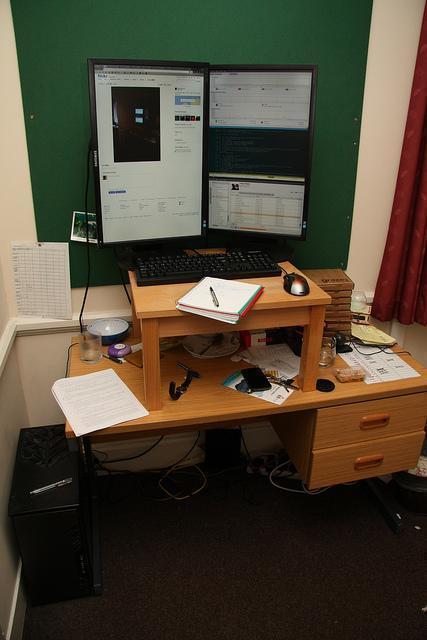Where does the black and silver item in the middle compartment belong?
Choose the right answer from the provided options to respond to the question.
Options: Ankle, neck, wrist, waist. Wrist. 